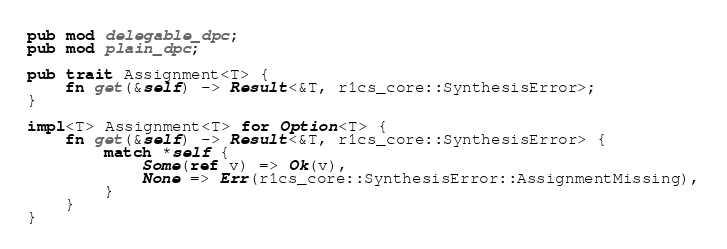Convert code to text. <code><loc_0><loc_0><loc_500><loc_500><_Rust_>pub mod delegable_dpc;
pub mod plain_dpc;

pub trait Assignment<T> {
    fn get(&self) -> Result<&T, r1cs_core::SynthesisError>;
}

impl<T> Assignment<T> for Option<T> {
    fn get(&self) -> Result<&T, r1cs_core::SynthesisError> {
        match *self {
            Some(ref v) => Ok(v),
            None => Err(r1cs_core::SynthesisError::AssignmentMissing),
        }
    }
}
</code> 